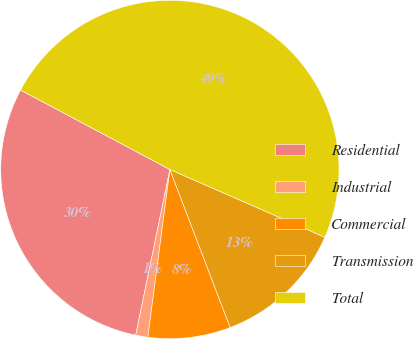Convert chart to OTSL. <chart><loc_0><loc_0><loc_500><loc_500><pie_chart><fcel>Residential<fcel>Industrial<fcel>Commercial<fcel>Transmission<fcel>Total<nl><fcel>29.54%<fcel>1.16%<fcel>7.88%<fcel>12.64%<fcel>48.78%<nl></chart> 